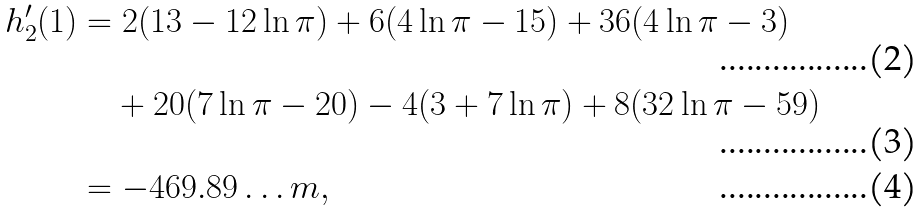Convert formula to latex. <formula><loc_0><loc_0><loc_500><loc_500>h _ { 2 } ^ { \prime } ( 1 ) & = 2 ( 1 3 - 1 2 \ln \pi ) + 6 ( 4 \ln \pi - 1 5 ) + 3 6 ( 4 \ln \pi - 3 ) \\ & \quad + 2 0 ( 7 \ln \pi - 2 0 ) - 4 ( 3 + 7 \ln \pi ) + 8 ( 3 2 \ln \pi - 5 9 ) \\ & = - 4 6 9 . 8 9 \dots m ,</formula> 